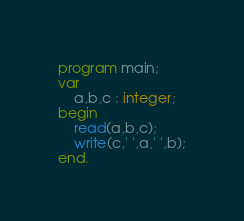Convert code to text. <code><loc_0><loc_0><loc_500><loc_500><_Pascal_>program main;
var
	a,b,c : integer;
begin
	read(a,b,c);
    write(c,' ',a,' ',b);
end.</code> 